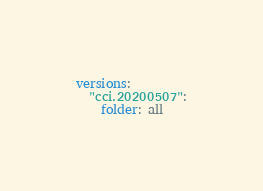<code> <loc_0><loc_0><loc_500><loc_500><_YAML_>versions:
  "cci.20200507":
    folder: all
</code> 